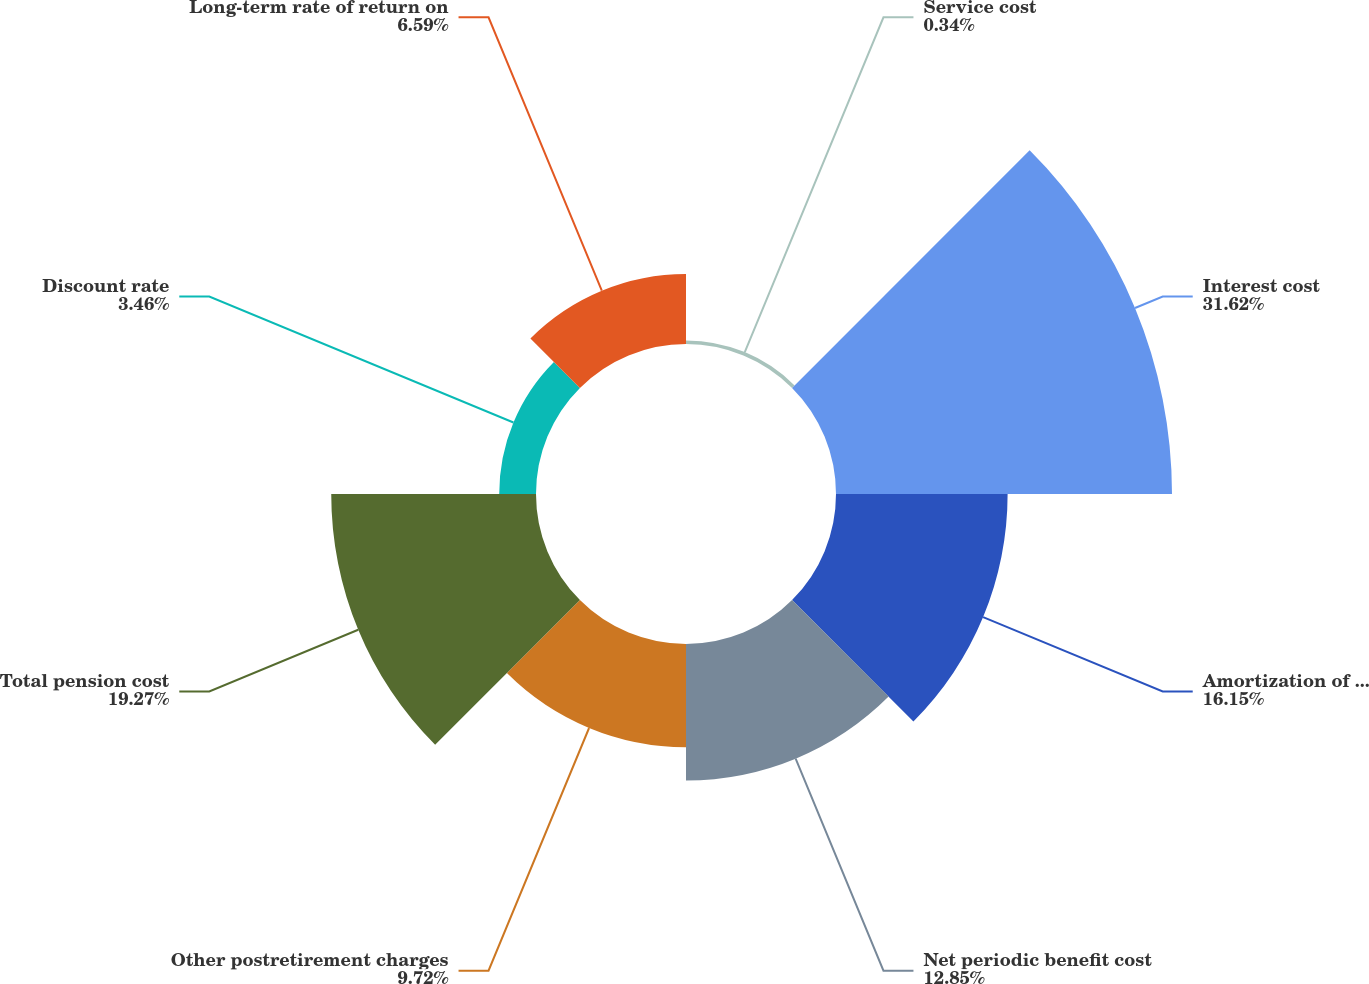Convert chart. <chart><loc_0><loc_0><loc_500><loc_500><pie_chart><fcel>Service cost<fcel>Interest cost<fcel>Amortization of actuarial loss<fcel>Net periodic benefit cost<fcel>Other postretirement charges<fcel>Total pension cost<fcel>Discount rate<fcel>Long-term rate of return on<nl><fcel>0.34%<fcel>31.62%<fcel>16.15%<fcel>12.85%<fcel>9.72%<fcel>19.27%<fcel>3.46%<fcel>6.59%<nl></chart> 